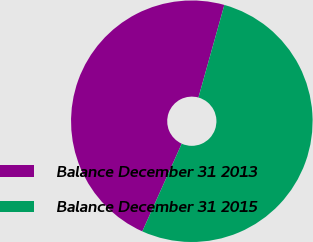Convert chart to OTSL. <chart><loc_0><loc_0><loc_500><loc_500><pie_chart><fcel>Balance December 31 2013<fcel>Balance December 31 2015<nl><fcel>47.62%<fcel>52.38%<nl></chart> 